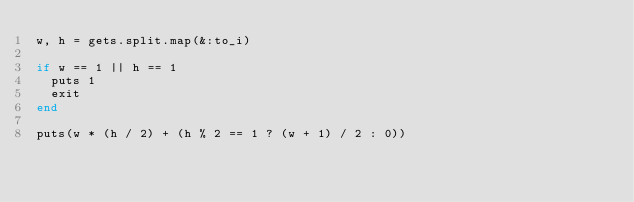Convert code to text. <code><loc_0><loc_0><loc_500><loc_500><_Ruby_>w, h = gets.split.map(&:to_i)

if w == 1 || h == 1
  puts 1
  exit
end

puts(w * (h / 2) + (h % 2 == 1 ? (w + 1) / 2 : 0))
</code> 